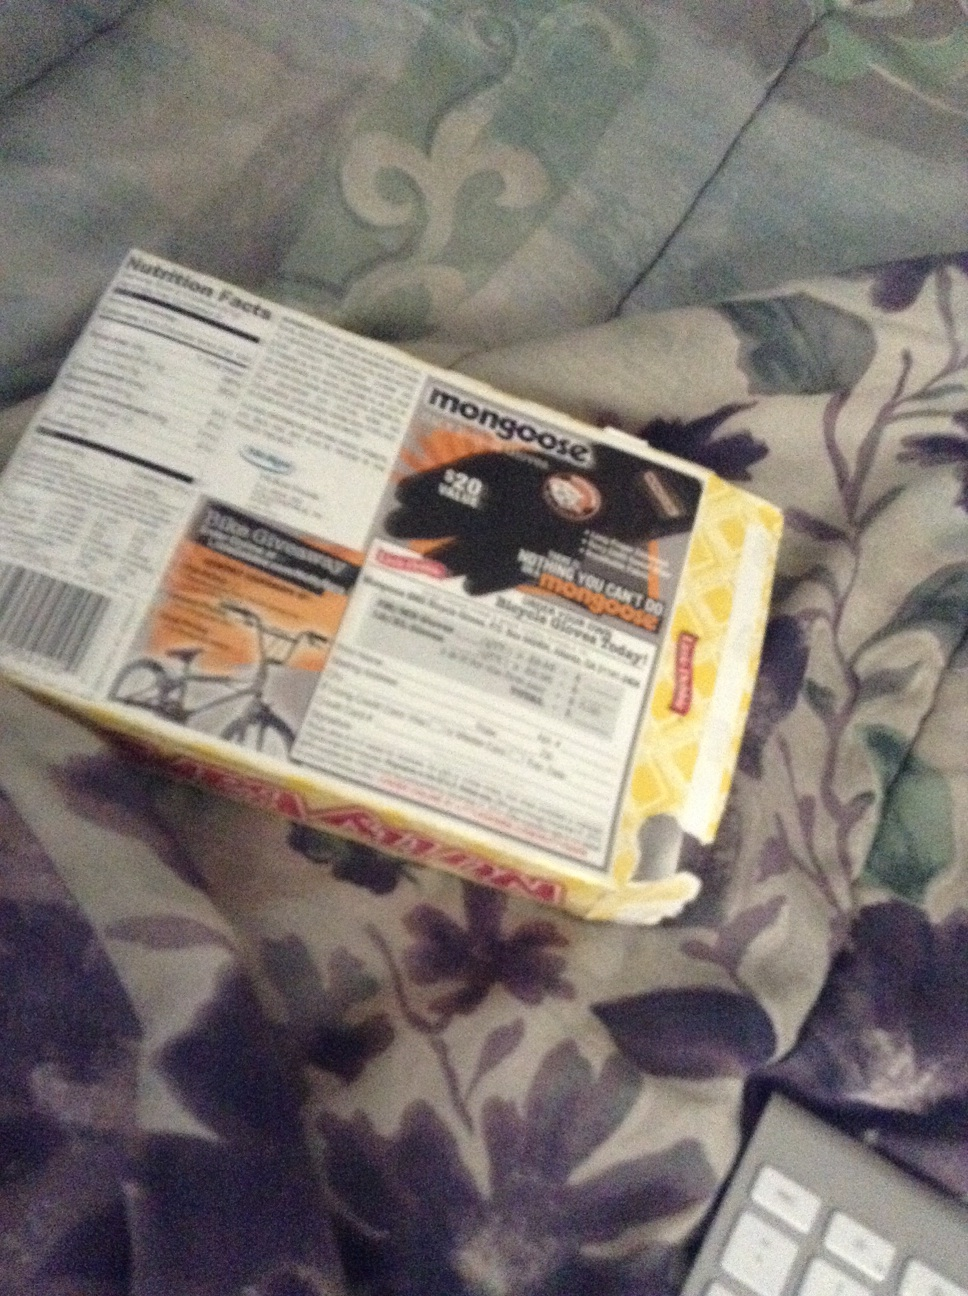What kind of person would find this product useful? This product would be particularly useful for avid cyclists who often engage in long-distance rides or mountain biking. It would also benefit those who cycle in varying weather conditions as the gloves offer a reliable grip and comfort. What might be a day in the life of someone using these gloves? A typical day for someone using these Mongoose cycling gloves might start early in the morning with a thorough check of their biking gear and ensuring these gloves are securely packed. They might then set off on a scenic but challenging trail, encountering various terrains and weather conditions. The gloves would offer them comfort and reliability throughout the ride, from smooth tarmac roads to rocky mountain paths. Throughout the day, the cyclist may attend to other related activities like maintaining their bike and preparing for the next adventure, always keeping the gloves handy for future excursions. Create a short story about a fictional character who uses these gloves for an epic biking adventure. In a small mountain village, there lived a young adventurer named Arlo. Gifted a pair of Mongoose cycling gloves by his grandfather, he set off on an epic journey to explore the legendary Silver Peak. The mountain was known for its treacherous paths and unpredictable weather. Arlo's gloves offered him superb grip and comfort as he navigated through dense forests, across roaring rivers, and up steep rocky cliffs. Despite the challenges, Arlo's determination and the reliability of his trusty gloves saw him through. Reaching the peak, he discovered a hidden cave glistening with ancient crystals, marking the end of a successful and legendary adventure. 